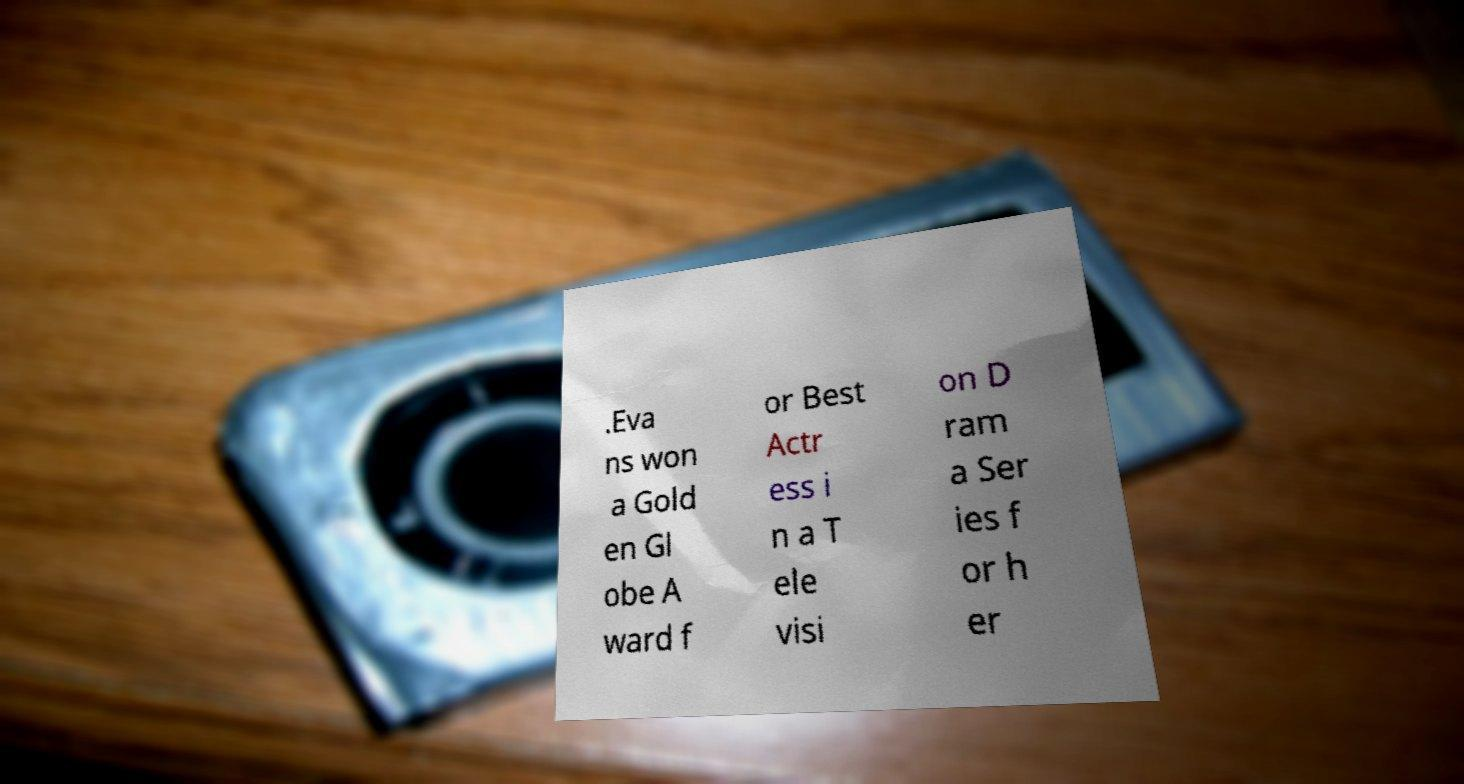Please read and relay the text visible in this image. What does it say? .Eva ns won a Gold en Gl obe A ward f or Best Actr ess i n a T ele visi on D ram a Ser ies f or h er 